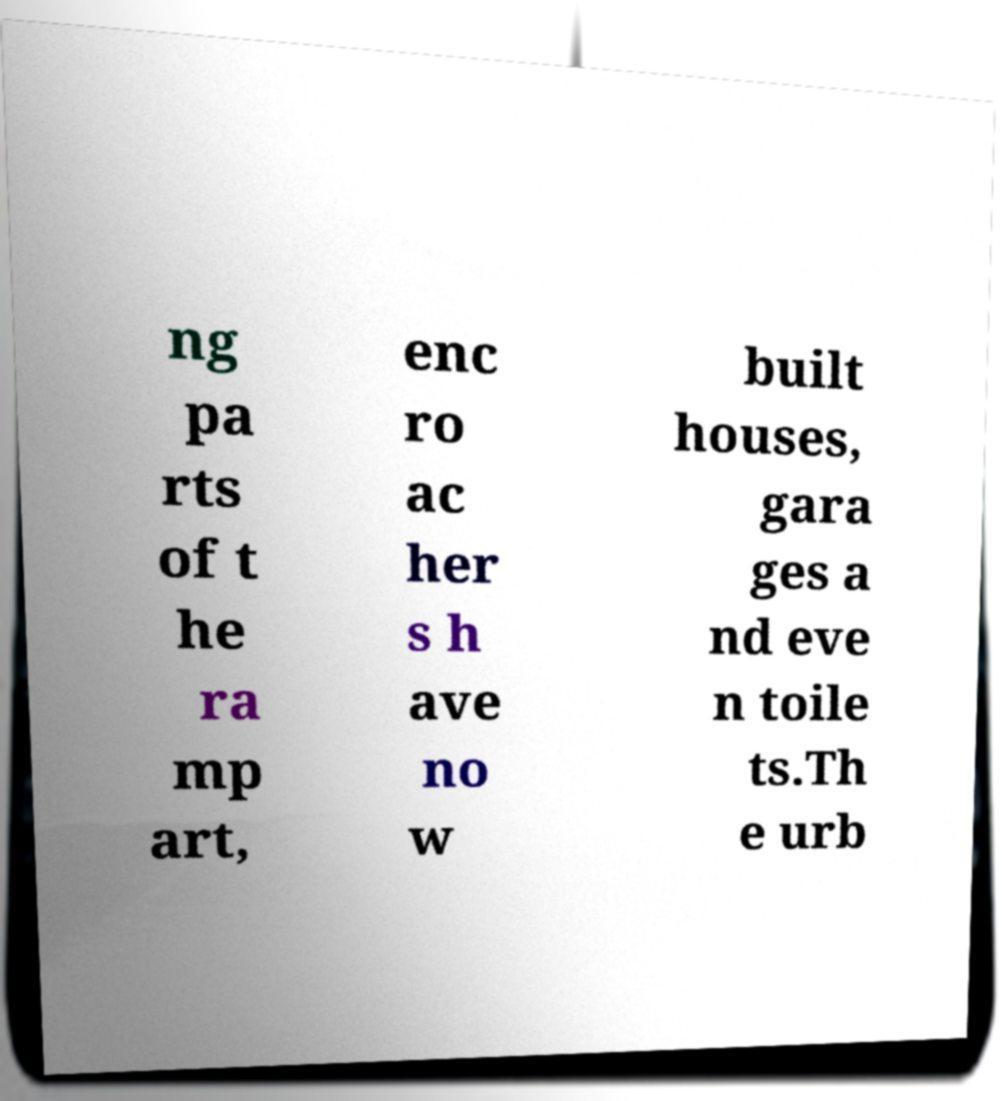There's text embedded in this image that I need extracted. Can you transcribe it verbatim? ng pa rts of t he ra mp art, enc ro ac her s h ave no w built houses, gara ges a nd eve n toile ts.Th e urb 